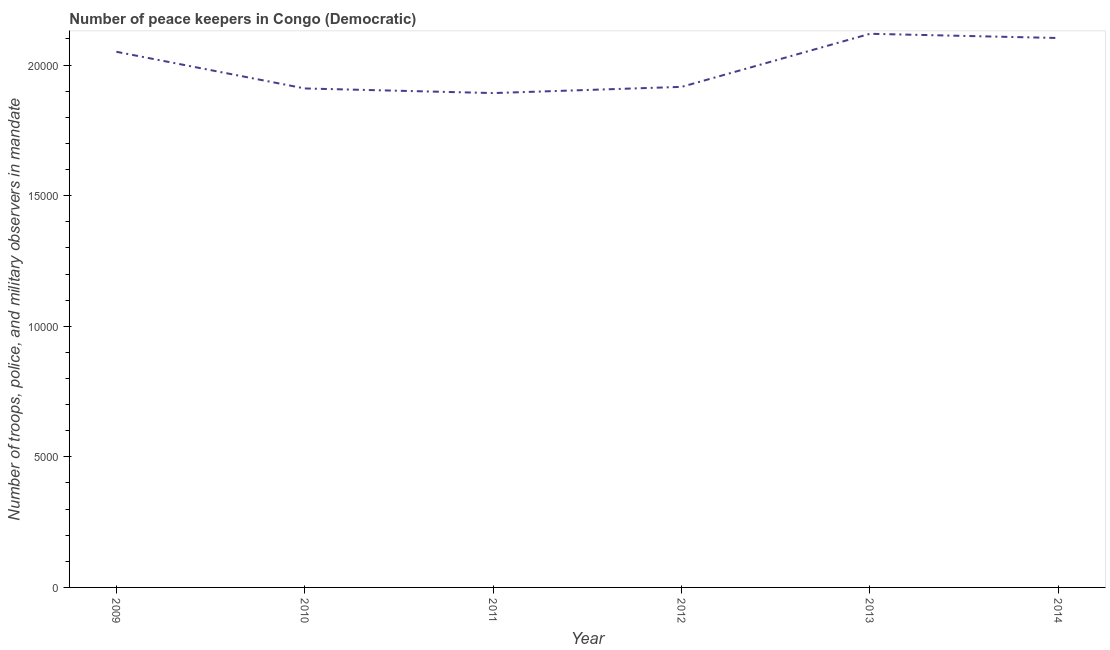What is the number of peace keepers in 2009?
Provide a succinct answer. 2.05e+04. Across all years, what is the maximum number of peace keepers?
Your response must be concise. 2.12e+04. Across all years, what is the minimum number of peace keepers?
Keep it short and to the point. 1.89e+04. In which year was the number of peace keepers minimum?
Offer a terse response. 2011. What is the sum of the number of peace keepers?
Give a very brief answer. 1.20e+05. What is the difference between the number of peace keepers in 2009 and 2012?
Your answer should be very brief. 1343. What is the average number of peace keepers per year?
Offer a terse response. 2.00e+04. What is the median number of peace keepers?
Provide a succinct answer. 1.98e+04. Do a majority of the years between 2013 and 2011 (inclusive) have number of peace keepers greater than 5000 ?
Offer a very short reply. No. What is the ratio of the number of peace keepers in 2013 to that in 2014?
Your response must be concise. 1.01. Is the difference between the number of peace keepers in 2011 and 2012 greater than the difference between any two years?
Offer a terse response. No. What is the difference between the highest and the second highest number of peace keepers?
Your answer should be compact. 162. Is the sum of the number of peace keepers in 2009 and 2010 greater than the maximum number of peace keepers across all years?
Your answer should be very brief. Yes. What is the difference between the highest and the lowest number of peace keepers?
Keep it short and to the point. 2270. In how many years, is the number of peace keepers greater than the average number of peace keepers taken over all years?
Ensure brevity in your answer.  3. How many years are there in the graph?
Offer a terse response. 6. What is the difference between two consecutive major ticks on the Y-axis?
Offer a very short reply. 5000. What is the title of the graph?
Your answer should be compact. Number of peace keepers in Congo (Democratic). What is the label or title of the Y-axis?
Provide a short and direct response. Number of troops, police, and military observers in mandate. What is the Number of troops, police, and military observers in mandate in 2009?
Your answer should be very brief. 2.05e+04. What is the Number of troops, police, and military observers in mandate of 2010?
Offer a terse response. 1.91e+04. What is the Number of troops, police, and military observers in mandate in 2011?
Give a very brief answer. 1.89e+04. What is the Number of troops, police, and military observers in mandate in 2012?
Your answer should be very brief. 1.92e+04. What is the Number of troops, police, and military observers in mandate in 2013?
Your answer should be compact. 2.12e+04. What is the Number of troops, police, and military observers in mandate of 2014?
Your response must be concise. 2.10e+04. What is the difference between the Number of troops, police, and military observers in mandate in 2009 and 2010?
Offer a terse response. 1404. What is the difference between the Number of troops, police, and military observers in mandate in 2009 and 2011?
Give a very brief answer. 1581. What is the difference between the Number of troops, police, and military observers in mandate in 2009 and 2012?
Offer a terse response. 1343. What is the difference between the Number of troops, police, and military observers in mandate in 2009 and 2013?
Your answer should be compact. -689. What is the difference between the Number of troops, police, and military observers in mandate in 2009 and 2014?
Ensure brevity in your answer.  -527. What is the difference between the Number of troops, police, and military observers in mandate in 2010 and 2011?
Give a very brief answer. 177. What is the difference between the Number of troops, police, and military observers in mandate in 2010 and 2012?
Offer a very short reply. -61. What is the difference between the Number of troops, police, and military observers in mandate in 2010 and 2013?
Keep it short and to the point. -2093. What is the difference between the Number of troops, police, and military observers in mandate in 2010 and 2014?
Make the answer very short. -1931. What is the difference between the Number of troops, police, and military observers in mandate in 2011 and 2012?
Keep it short and to the point. -238. What is the difference between the Number of troops, police, and military observers in mandate in 2011 and 2013?
Provide a short and direct response. -2270. What is the difference between the Number of troops, police, and military observers in mandate in 2011 and 2014?
Offer a very short reply. -2108. What is the difference between the Number of troops, police, and military observers in mandate in 2012 and 2013?
Ensure brevity in your answer.  -2032. What is the difference between the Number of troops, police, and military observers in mandate in 2012 and 2014?
Your response must be concise. -1870. What is the difference between the Number of troops, police, and military observers in mandate in 2013 and 2014?
Offer a very short reply. 162. What is the ratio of the Number of troops, police, and military observers in mandate in 2009 to that in 2010?
Your answer should be compact. 1.07. What is the ratio of the Number of troops, police, and military observers in mandate in 2009 to that in 2011?
Offer a terse response. 1.08. What is the ratio of the Number of troops, police, and military observers in mandate in 2009 to that in 2012?
Your answer should be very brief. 1.07. What is the ratio of the Number of troops, police, and military observers in mandate in 2009 to that in 2014?
Provide a succinct answer. 0.97. What is the ratio of the Number of troops, police, and military observers in mandate in 2010 to that in 2011?
Ensure brevity in your answer.  1.01. What is the ratio of the Number of troops, police, and military observers in mandate in 2010 to that in 2012?
Offer a terse response. 1. What is the ratio of the Number of troops, police, and military observers in mandate in 2010 to that in 2013?
Your response must be concise. 0.9. What is the ratio of the Number of troops, police, and military observers in mandate in 2010 to that in 2014?
Provide a short and direct response. 0.91. What is the ratio of the Number of troops, police, and military observers in mandate in 2011 to that in 2013?
Your answer should be very brief. 0.89. What is the ratio of the Number of troops, police, and military observers in mandate in 2012 to that in 2013?
Give a very brief answer. 0.9. What is the ratio of the Number of troops, police, and military observers in mandate in 2012 to that in 2014?
Ensure brevity in your answer.  0.91. What is the ratio of the Number of troops, police, and military observers in mandate in 2013 to that in 2014?
Provide a short and direct response. 1.01. 